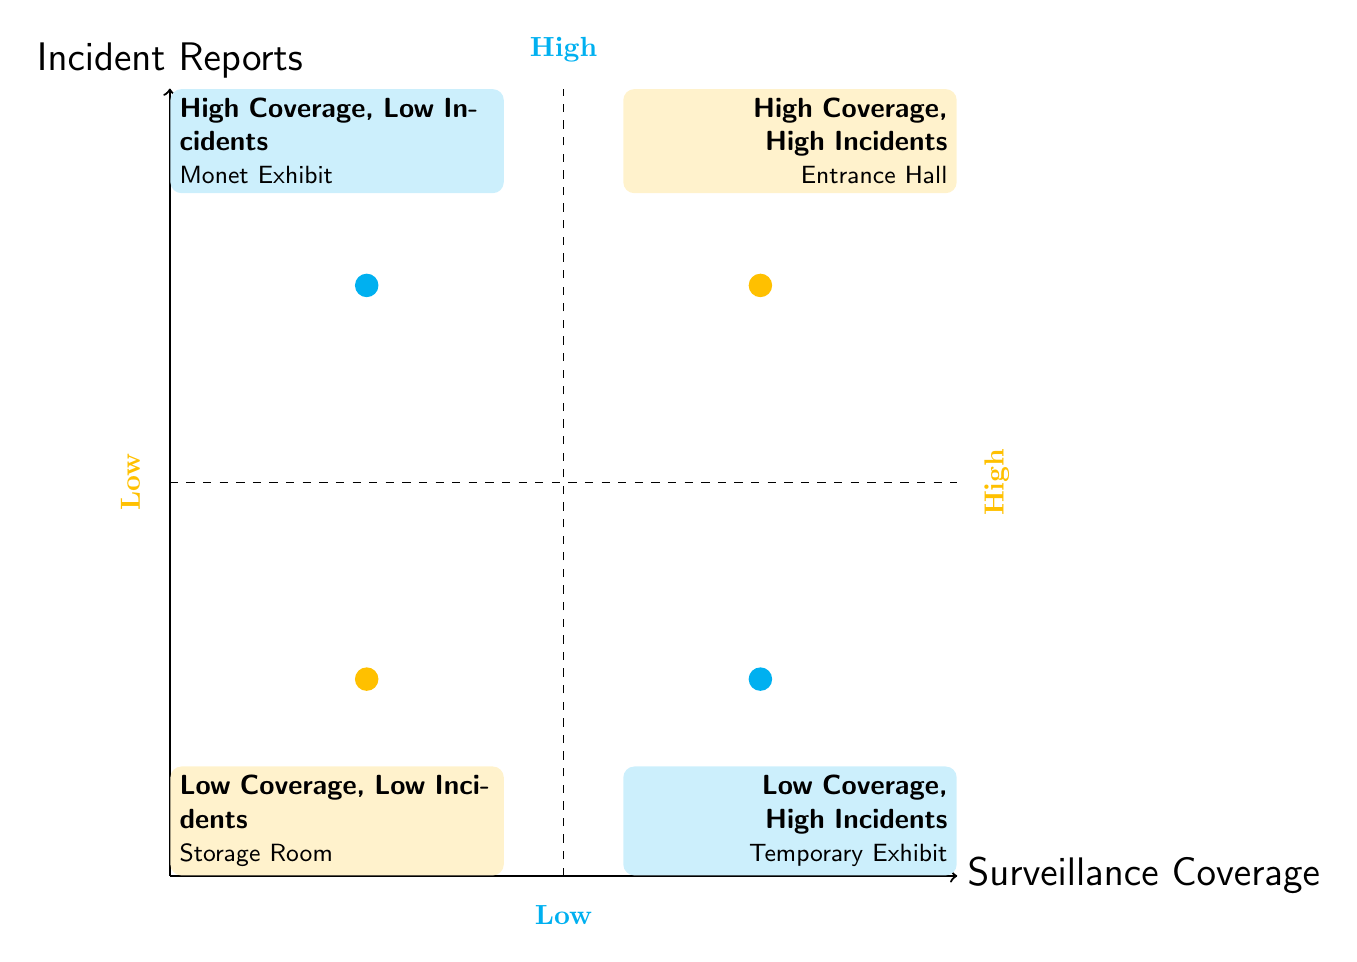What area has high surveillance coverage and low incident reports? The diagram displays the "Monet Exhibit" in the quadrant where surveillance coverage is high and incident reports are low, indicating it has good monitoring with few incidents.
Answer: Monet Exhibit Which area has high incident reports? The diagram indicates that both the "Entrance Hall" and the "Temporary Exhibit" have high incident reports, as they are located in the higher segment of incident reports regardless of coverage.
Answer: Entrance Hall, Temporary Exhibit How many areas have low surveillance coverage? By counting the quadrants, it shows there are two areas with low surveillance coverage: "Storage Room" and "Temporary Exhibit".
Answer: 2 What type of relationship exists between high surveillance coverage and incident reports based on the diagram? The relationship shows that high surveillance coverage can correspond to both low ("Monet Exhibit") and high incident reports ("Entrance Hall"), indicating that coverage alone does not determine the frequency of incidents.
Answer: Mixed relationship Which area represents low surveillance coverage and low incident incidents? The diagram places the "Storage Room" in the quadrant representing low surveillance coverage and low incident reports, making it clear that this area is less monitored with few occurrences of incidents.
Answer: Storage Room In which quadrant would you find the "Temporary Exhibit"? The "Temporary Exhibit" is located in the quadrant where there is low surveillance coverage but high incident reports, indicating this area is less monitored but has frequent incidents.
Answer: Low Coverage, High Incidents If we compare the "Monet Exhibit" and the "Entrance Hall", which has more incident reports? The "Entrance Hall" has more incident reports as it is located in the high incident quadrant, while the "Monet Exhibit" is in the low incident quadrant.
Answer: Entrance Hall What color indicates high surveillance coverage in the diagram? The color representing high surveillance coverage in the diagram for the quadrants is the impressionist shade, which is indicative of instances where surveillance is robust.
Answer: Impressionist 